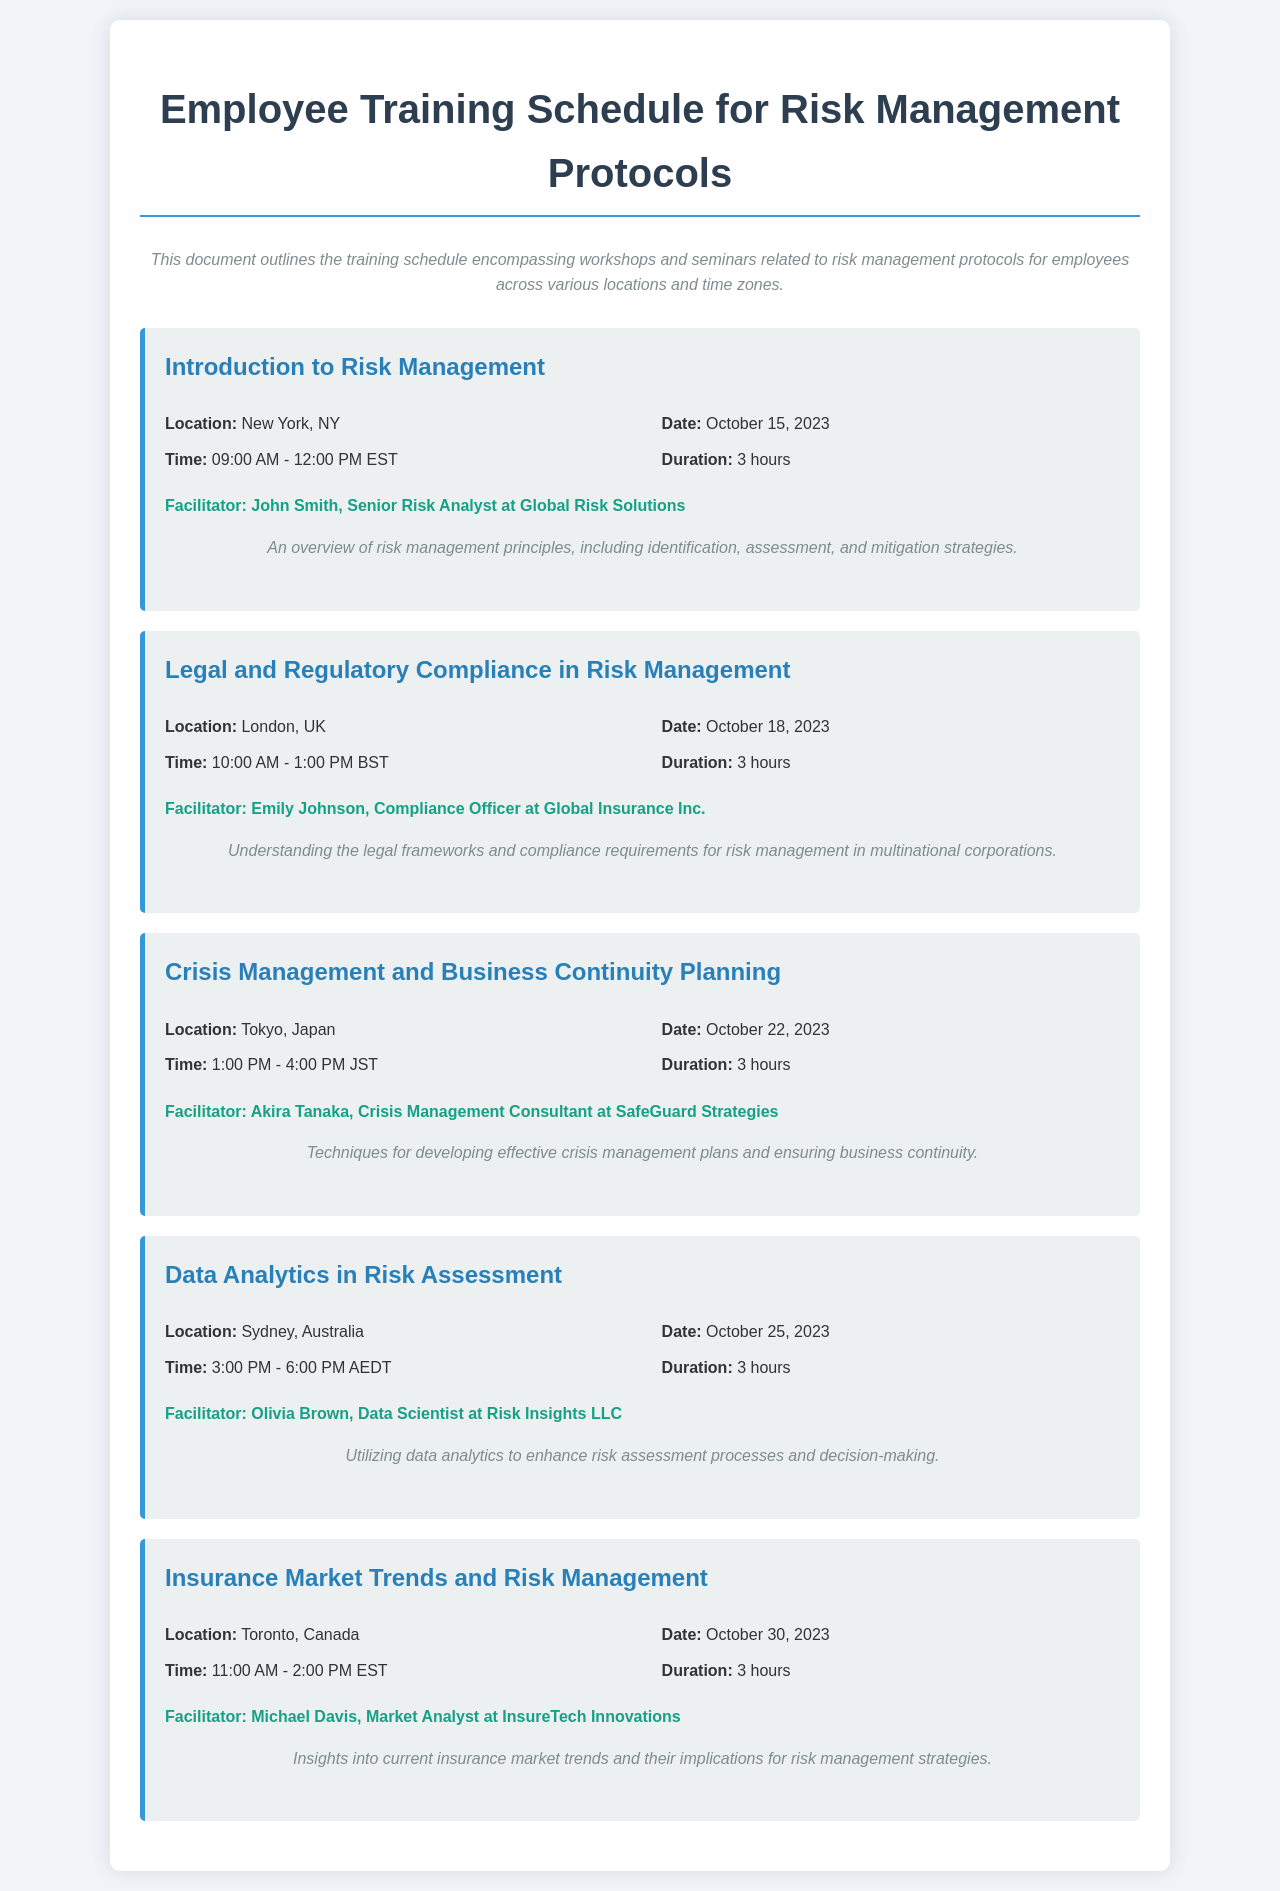What is the title of the document? The title is stated at the top of the document, which is "Employee Training Schedule for Risk Management Protocols."
Answer: Employee Training Schedule for Risk Management Protocols Who is the facilitator for the session on "Data Analytics in Risk Assessment"? The document lists the facilitator for this session as Olivia Brown, who is identified as a Data Scientist at Risk Insights LLC.
Answer: Olivia Brown What is the date of the workshop titled "Legal and Regulatory Compliance in Risk Management"? The date is provided within the session information section of the respective workshop, which is October 18, 2023.
Answer: October 18, 2023 What is the duration of each training session? The document specifies that each training session lasts for 3 hours, as indicated in the duration section of each session.
Answer: 3 hours What time does the session in Tokyo start? The start time for the session in Tokyo is indicated as 1:00 PM JST in the session information.
Answer: 1:00 PM Which location hosts the "Insurance Market Trends and Risk Management" session? The document mentions Toronto, Canada, as the location for this particular session.
Answer: Toronto, Canada How many sessions are listed in this training schedule? By counting the sessions provided, there are five different training sessions listed in the document.
Answer: Five Which facilitator works at Global Insurance Inc.? The facilitators are listed in each session, and Emily Johnson is specifically stated to work at Global Insurance Inc.
Answer: Emily Johnson What is a focus topic of the "Crisis Management and Business Continuity Planning" workshop? The description of this workshop outlines that it covers "Techniques for developing effective crisis management plans and ensuring business continuity."
Answer: Crisis management plans and business continuity 